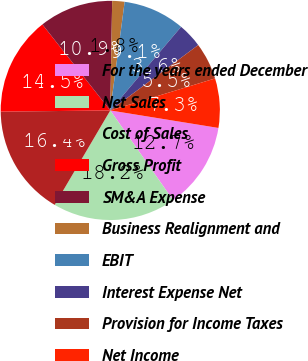Convert chart to OTSL. <chart><loc_0><loc_0><loc_500><loc_500><pie_chart><fcel>For the years ended December<fcel>Net Sales<fcel>Cost of Sales<fcel>Gross Profit<fcel>SM&A Expense<fcel>Business Realignment and<fcel>EBIT<fcel>Interest Expense Net<fcel>Provision for Income Taxes<fcel>Net Income<nl><fcel>12.73%<fcel>18.18%<fcel>16.36%<fcel>14.54%<fcel>10.91%<fcel>1.82%<fcel>9.09%<fcel>3.64%<fcel>5.46%<fcel>7.27%<nl></chart> 